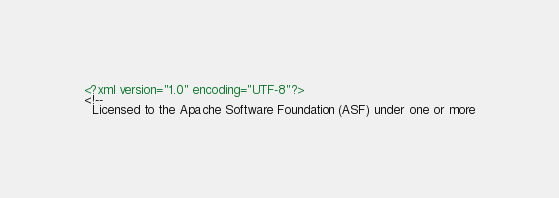<code> <loc_0><loc_0><loc_500><loc_500><_XML_><?xml version="1.0" encoding="UTF-8"?>
<!--
  Licensed to the Apache Software Foundation (ASF) under one or more</code> 